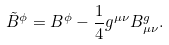<formula> <loc_0><loc_0><loc_500><loc_500>\tilde { B } ^ { \phi } = B ^ { \phi } - \frac { 1 } { 4 } g ^ { \mu \nu } B _ { \mu \nu } ^ { g } .</formula> 